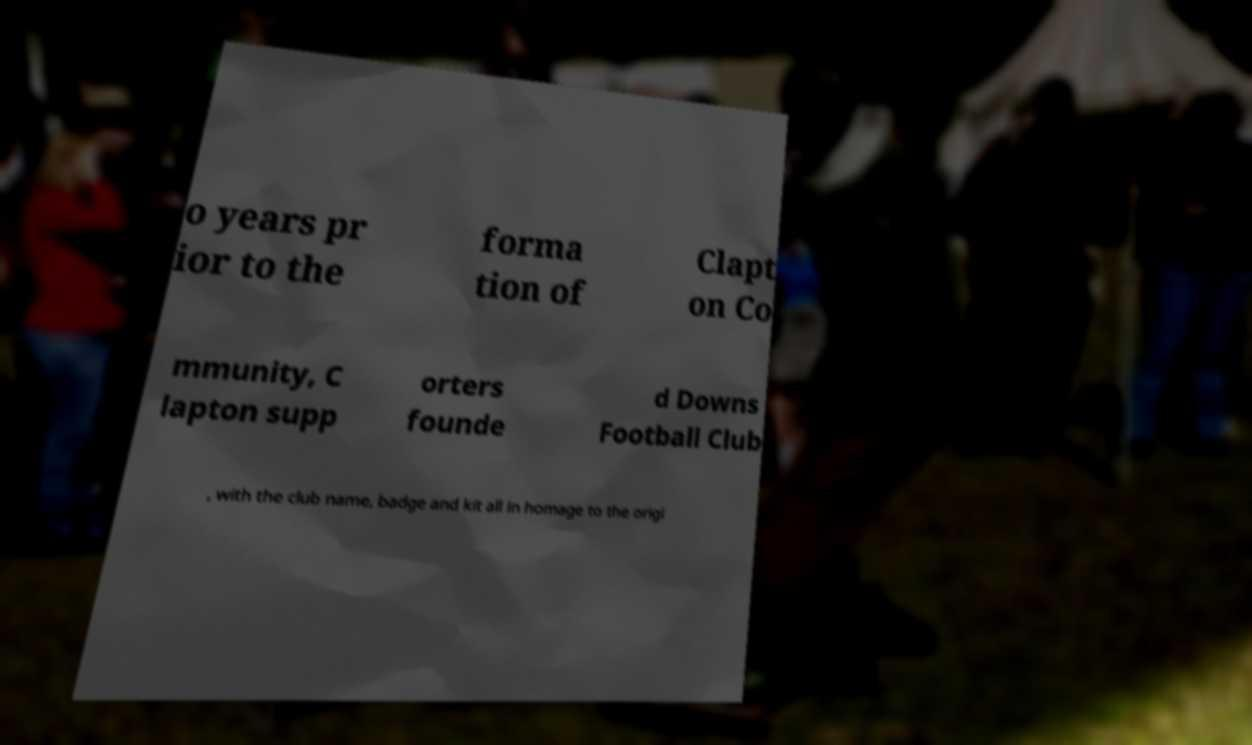Can you read and provide the text displayed in the image?This photo seems to have some interesting text. Can you extract and type it out for me? o years pr ior to the forma tion of Clapt on Co mmunity, C lapton supp orters founde d Downs Football Club , with the club name, badge and kit all in homage to the origi 